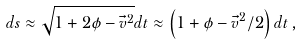<formula> <loc_0><loc_0><loc_500><loc_500>d s \approx \sqrt { 1 + 2 \phi - \vec { v } ^ { 2 } } d t \approx \left ( 1 + \phi - \vec { v } ^ { 2 } / 2 \right ) d t \, ,</formula> 